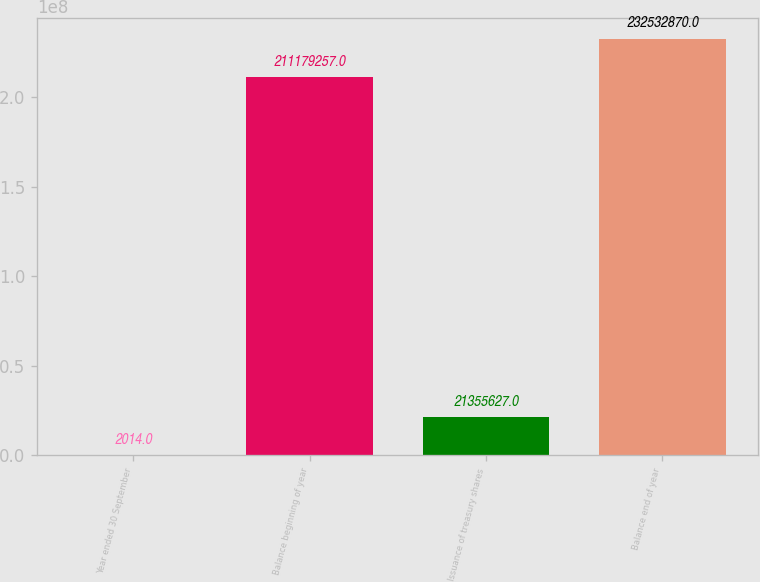<chart> <loc_0><loc_0><loc_500><loc_500><bar_chart><fcel>Year ended 30 September<fcel>Balance beginning of year<fcel>Issuance of treasury shares<fcel>Balance end of year<nl><fcel>2014<fcel>2.11179e+08<fcel>2.13556e+07<fcel>2.32533e+08<nl></chart> 